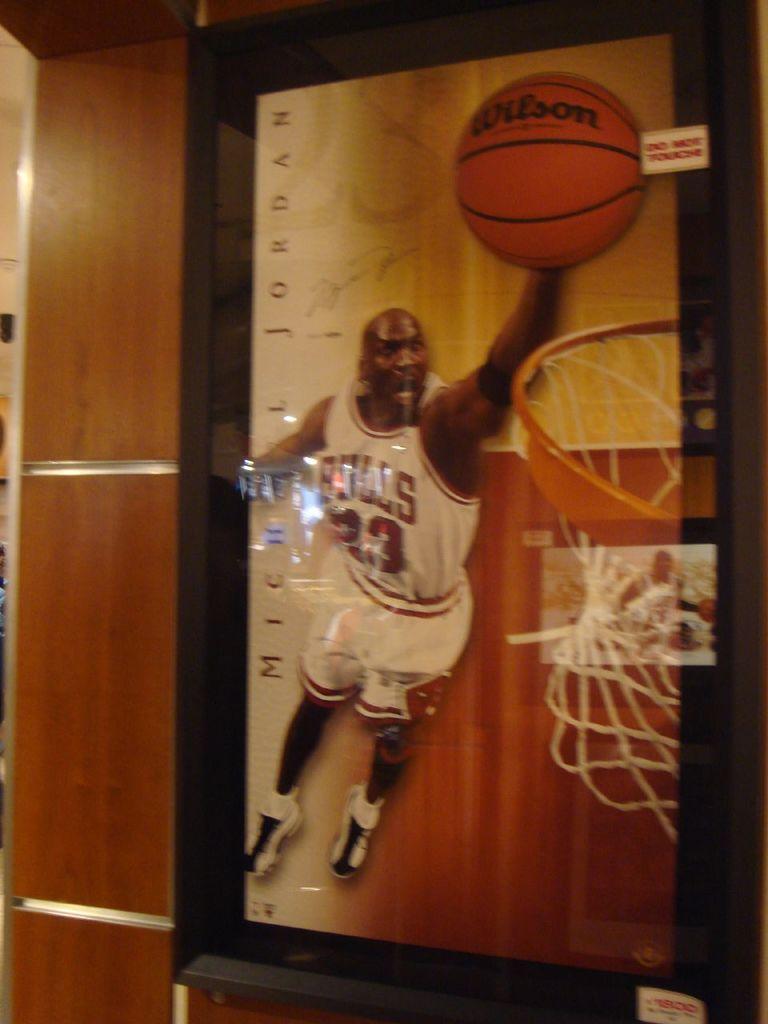What team name is on the jersey?
Make the answer very short. Bulls. What is the player's number?
Keep it short and to the point. 23. 